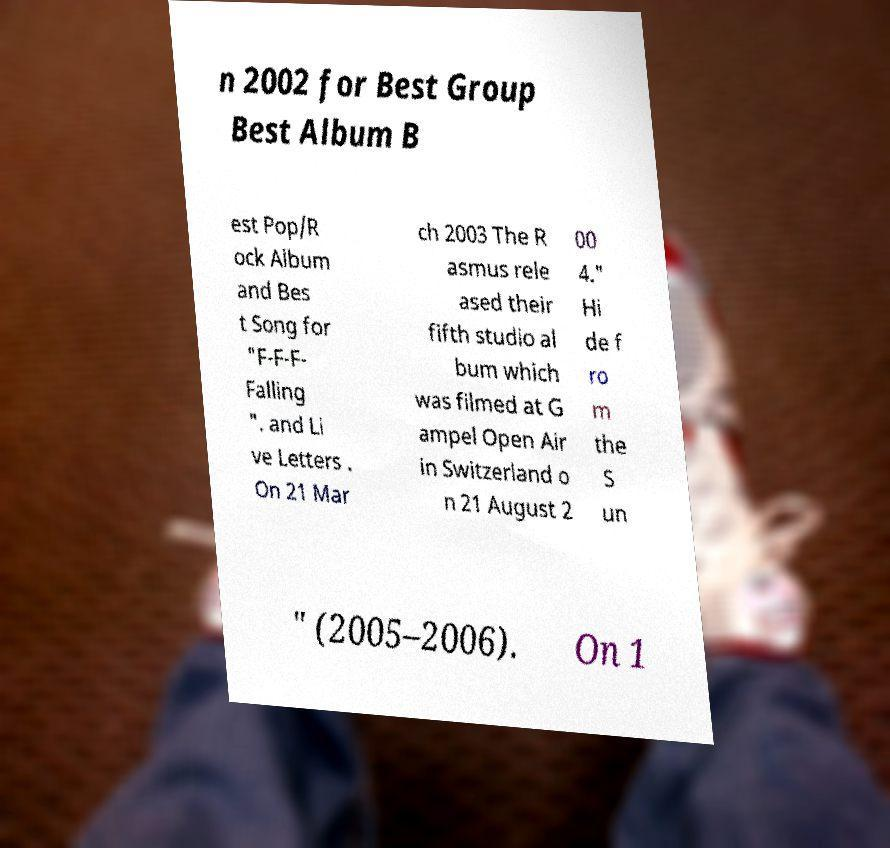There's text embedded in this image that I need extracted. Can you transcribe it verbatim? n 2002 for Best Group Best Album B est Pop/R ock Album and Bes t Song for "F-F-F- Falling ". and Li ve Letters . On 21 Mar ch 2003 The R asmus rele ased their fifth studio al bum which was filmed at G ampel Open Air in Switzerland o n 21 August 2 00 4." Hi de f ro m the S un " (2005–2006). On 1 